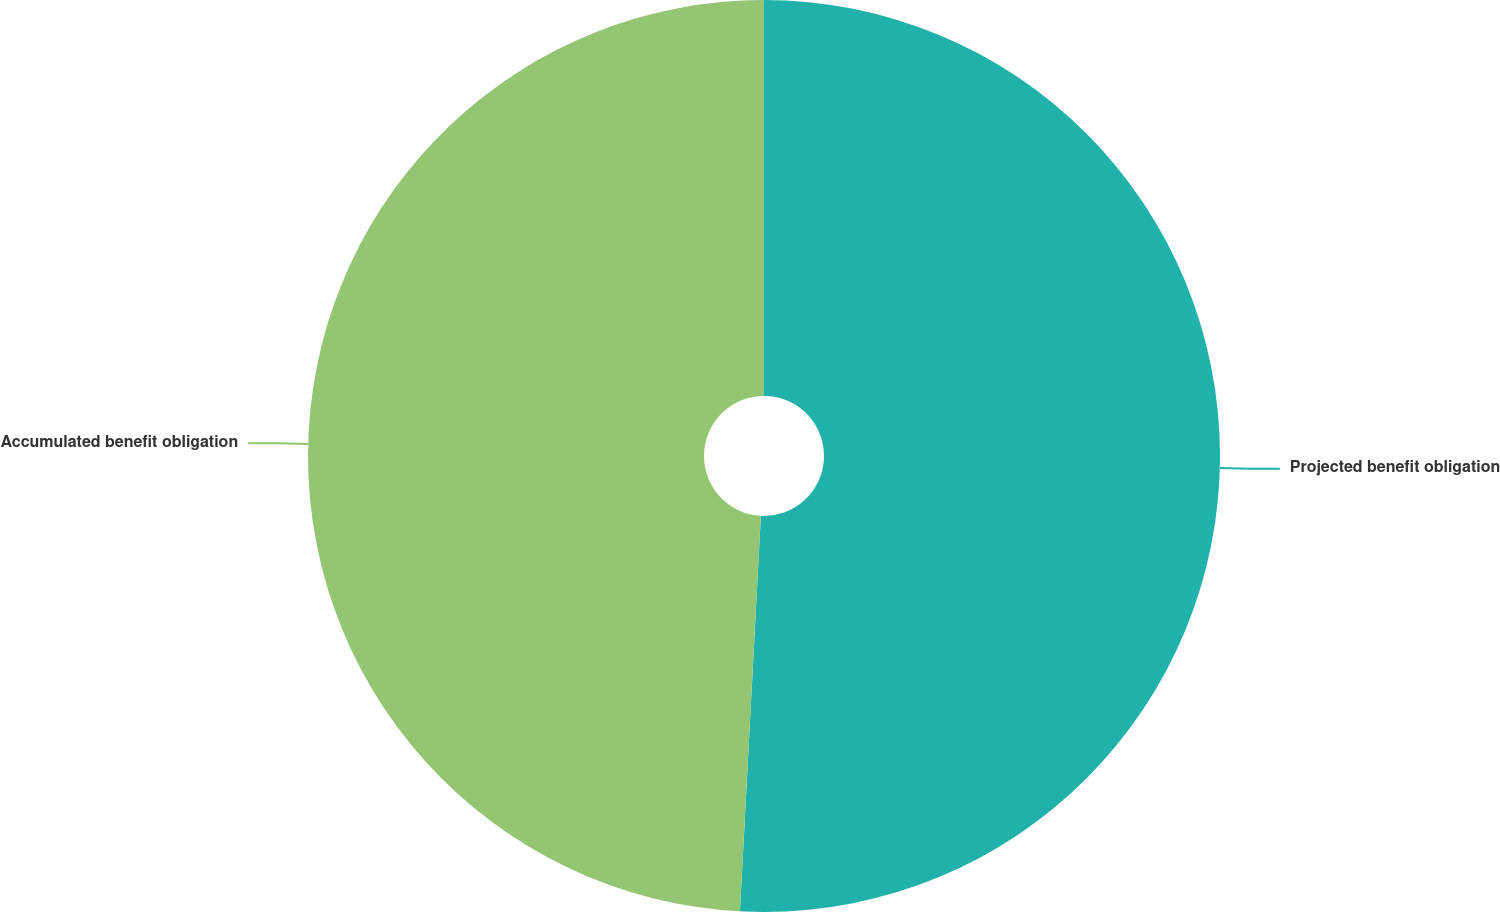Convert chart. <chart><loc_0><loc_0><loc_500><loc_500><pie_chart><fcel>Projected benefit obligation<fcel>Accumulated benefit obligation<nl><fcel>50.84%<fcel>49.16%<nl></chart> 